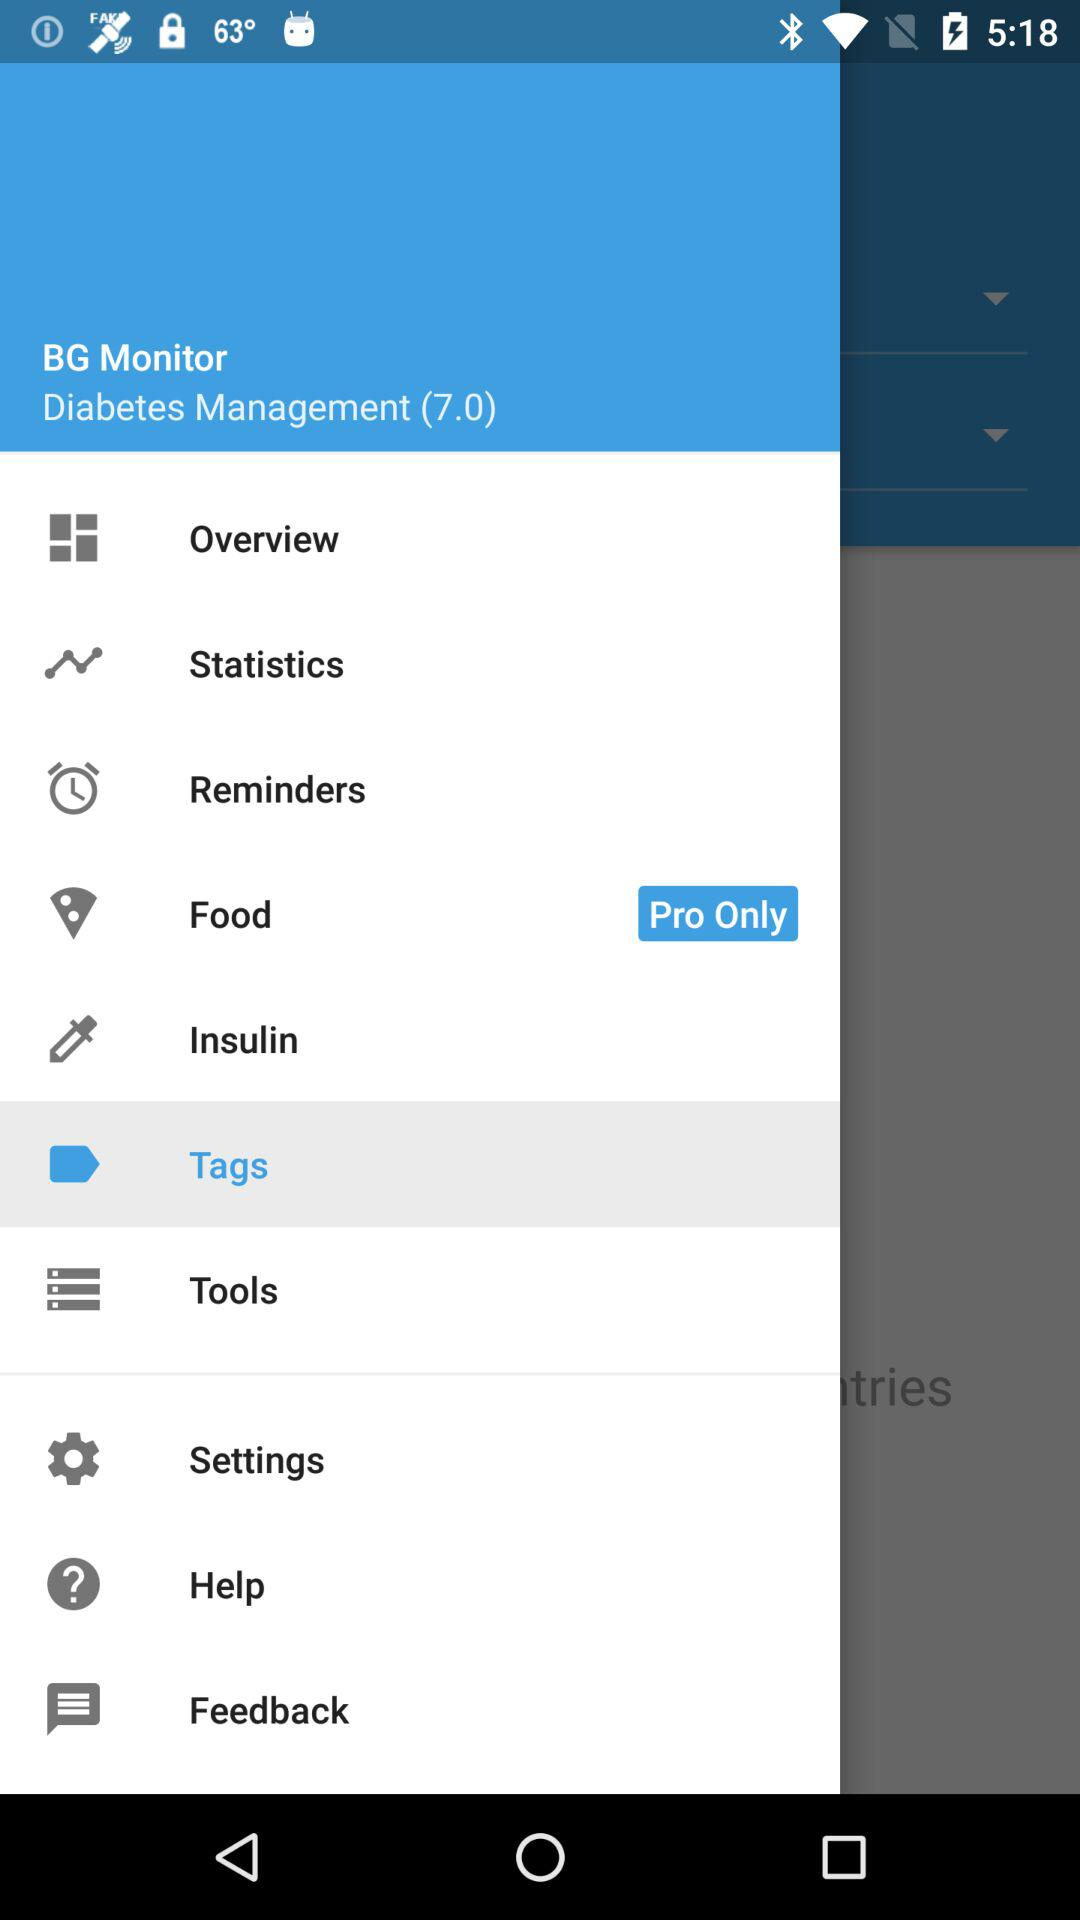Which option is selected? The selected option is "Tags". 